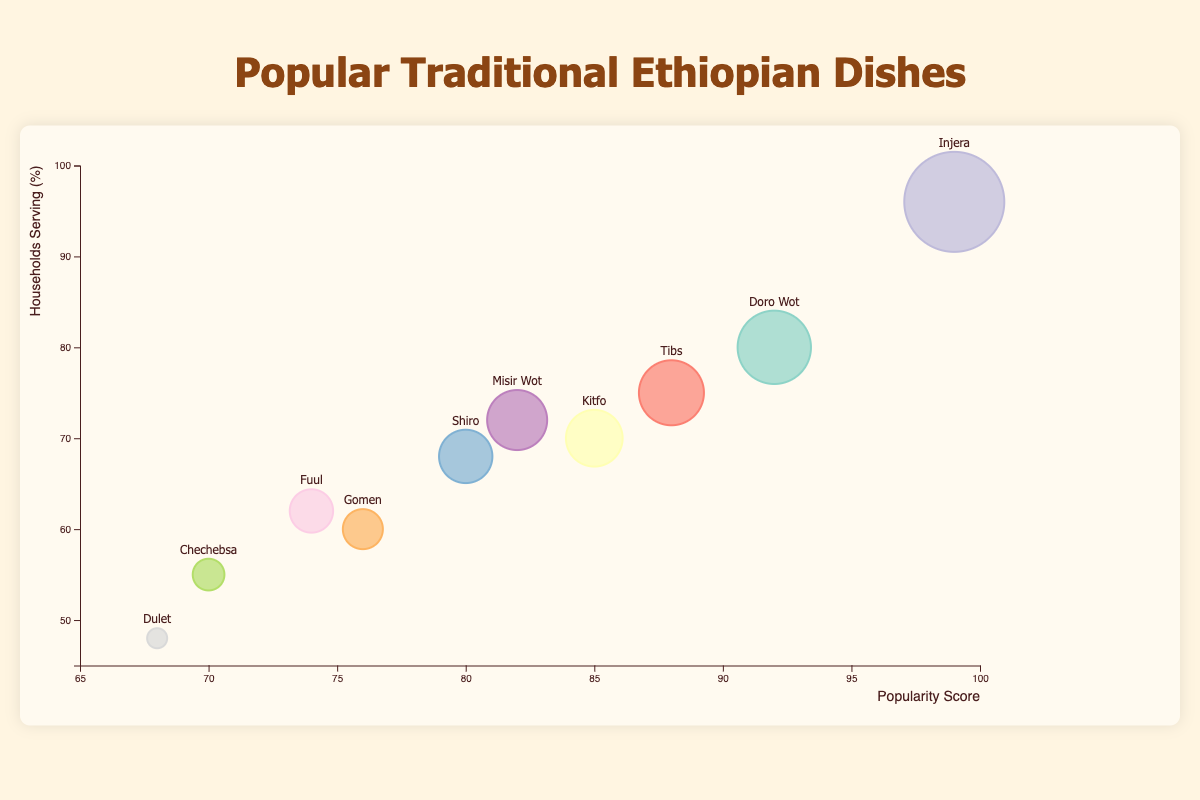What is the most popular traditional Ethiopian dish according to the bubble chart? Look for the bubble with the highest x-axis value, since the x-axis represents the popularity score. Injera has the highest popularity score of 99.
Answer: Injera Which dish has the highest number of households serving it? Check the y-axis value, as it represents the percentage of households serving the dish. Injera is the dish with the highest households serving percentage at 96%.
Answer: Injera How many dishes have a popularity score higher than 90? Identify the bubbles where the x-axis value (popularity score) is greater than 90. There are two dishes: Injera (99) and Doro Wot (92).
Answer: 2 Which dish has the lowest popularity score and how many households serve it? Find the bubble with the lowest x-axis value (popularity score). Dulet has the lowest popularity score of 68. The y-axis value for Dulet is 48%.
Answer: Dulet, 48% Compare the households serving percentage between Kitfo and Tibs. Which one is higher and by how much? Locate Kitfo and Tibs on the bubble chart and compare their y-axis values. Kitfo has 70% households serving it, and Tibs has 75%. Difference: 75% - 70% = 5%.
Answer: Tibs, by 5% What is the main ingredient common to more than one dish with a high popularity score (above 80)? Identify the dishes with popularity scores above 80 and check their main ingredients. Those dishes are Doro Wot, Kitfo, Injera, Tibs, Misir Wot. Common main ingredients: Berbere, Onions.
Answer: Berbere, Onions How does the popularity of Shiro compare to that of Misir Wot? Look at the x-axis values for Shiro (popularity score 80) and Misir Wot (popularity score 82). Misir Wot has a higher popularity score by 2 points.
Answer: Misir Wot is more popular by 2 points Which dish has a bubble with the largest size on the chart? The size of the bubble corresponds to the number of households serving the dish. The largest bubble is for Injera, indicating it has the highest households serving percentage (96%).
Answer: Injera Calculate the average popularity score of all dishes where the primary ingredient is 'Niter Kibbeh'. Identify the dishes containing Niter Kibbeh (Doro Wot, Kitfo, Gomen, Chechebsa) and find their popularity scores: 92, 85, 76, 70. Average = (92 + 85 + 76 + 70) / 4 = 80.75.
Answer: 80.75 